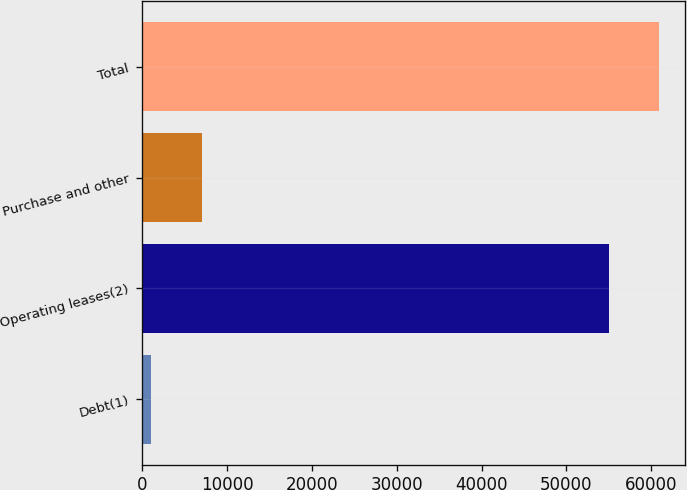Convert chart to OTSL. <chart><loc_0><loc_0><loc_500><loc_500><bar_chart><fcel>Debt(1)<fcel>Operating leases(2)<fcel>Purchase and other<fcel>Total<nl><fcel>1080<fcel>54969<fcel>7042<fcel>60931<nl></chart> 